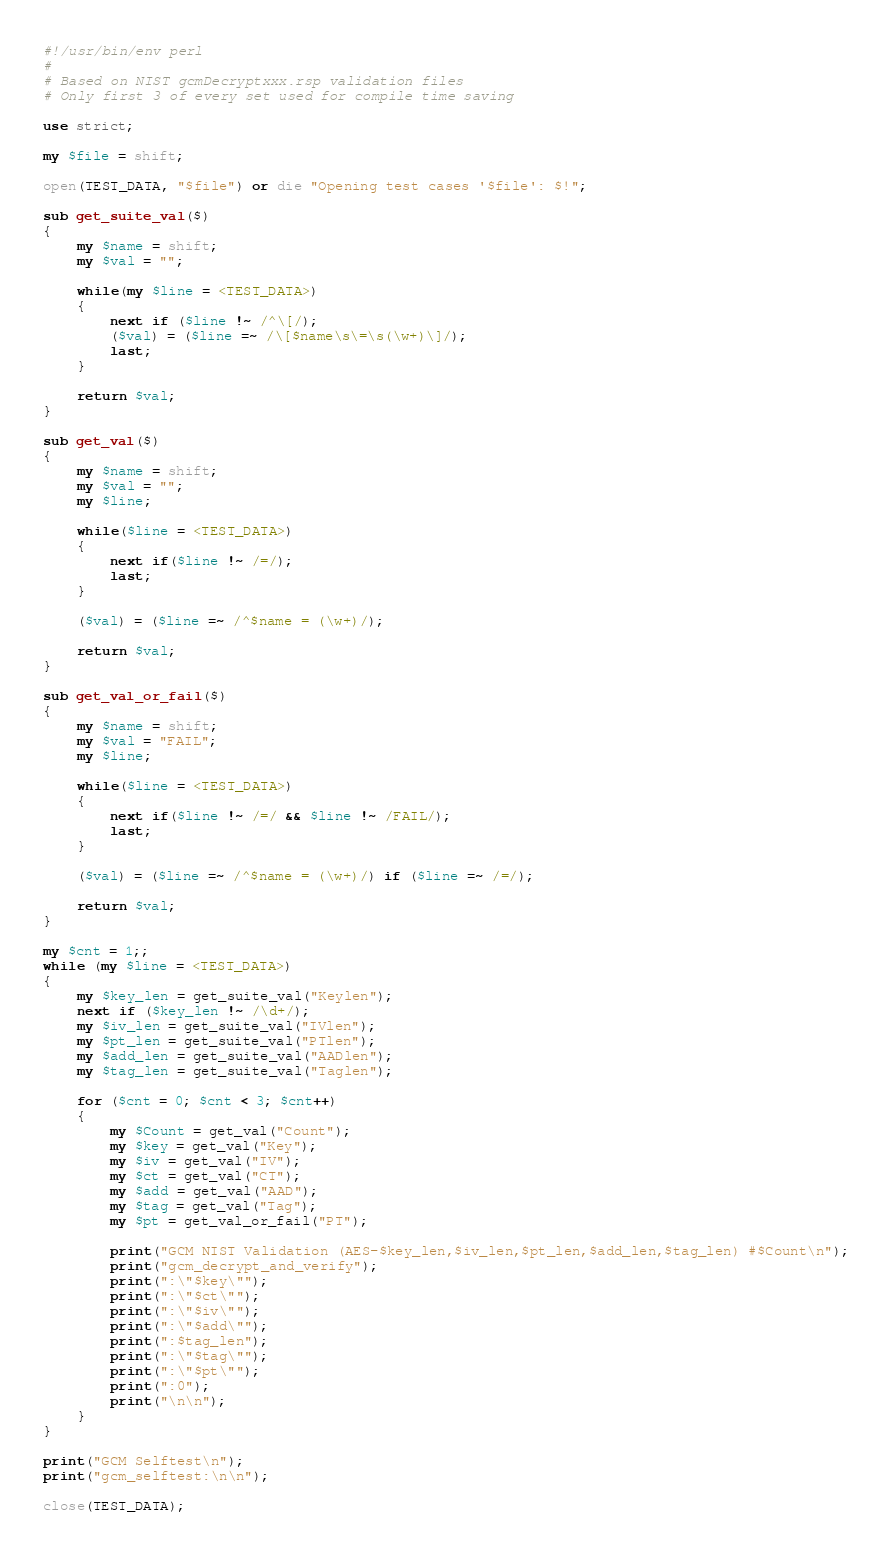Convert code to text. <code><loc_0><loc_0><loc_500><loc_500><_Perl_>#!/usr/bin/env perl
#
# Based on NIST gcmDecryptxxx.rsp validation files
# Only first 3 of every set used for compile time saving

use strict;

my $file = shift;

open(TEST_DATA, "$file") or die "Opening test cases '$file': $!";

sub get_suite_val($)
{
    my $name = shift;
    my $val = "";

    while(my $line = <TEST_DATA>)
    {
        next if ($line !~ /^\[/);
        ($val) = ($line =~ /\[$name\s\=\s(\w+)\]/);
        last;
    }

    return $val;
}

sub get_val($)
{
    my $name = shift;
    my $val = "";
    my $line;

    while($line = <TEST_DATA>)
    {
        next if($line !~ /=/);
        last;
    }

    ($val) = ($line =~ /^$name = (\w+)/);

    return $val;
}

sub get_val_or_fail($)
{
    my $name = shift;
    my $val = "FAIL";
    my $line;

    while($line = <TEST_DATA>)
    {
        next if($line !~ /=/ && $line !~ /FAIL/);
        last;
    }

    ($val) = ($line =~ /^$name = (\w+)/) if ($line =~ /=/);

    return $val;
}

my $cnt = 1;;
while (my $line = <TEST_DATA>)
{
    my $key_len = get_suite_val("Keylen");
    next if ($key_len !~ /\d+/);
    my $iv_len = get_suite_val("IVlen");
    my $pt_len = get_suite_val("PTlen");
    my $add_len = get_suite_val("AADlen");
    my $tag_len = get_suite_val("Taglen");

    for ($cnt = 0; $cnt < 3; $cnt++)
    {
        my $Count = get_val("Count");
        my $key = get_val("Key");
        my $iv = get_val("IV");
        my $ct = get_val("CT");
        my $add = get_val("AAD");
        my $tag = get_val("Tag");
        my $pt = get_val_or_fail("PT");

        print("GCM NIST Validation (AES-$key_len,$iv_len,$pt_len,$add_len,$tag_len) #$Count\n");
        print("gcm_decrypt_and_verify");
        print(":\"$key\"");
        print(":\"$ct\"");
        print(":\"$iv\"");
        print(":\"$add\"");
        print(":$tag_len");
        print(":\"$tag\"");
        print(":\"$pt\"");
        print(":0");
        print("\n\n");
    }
}

print("GCM Selftest\n");
print("gcm_selftest:\n\n");

close(TEST_DATA);
</code> 